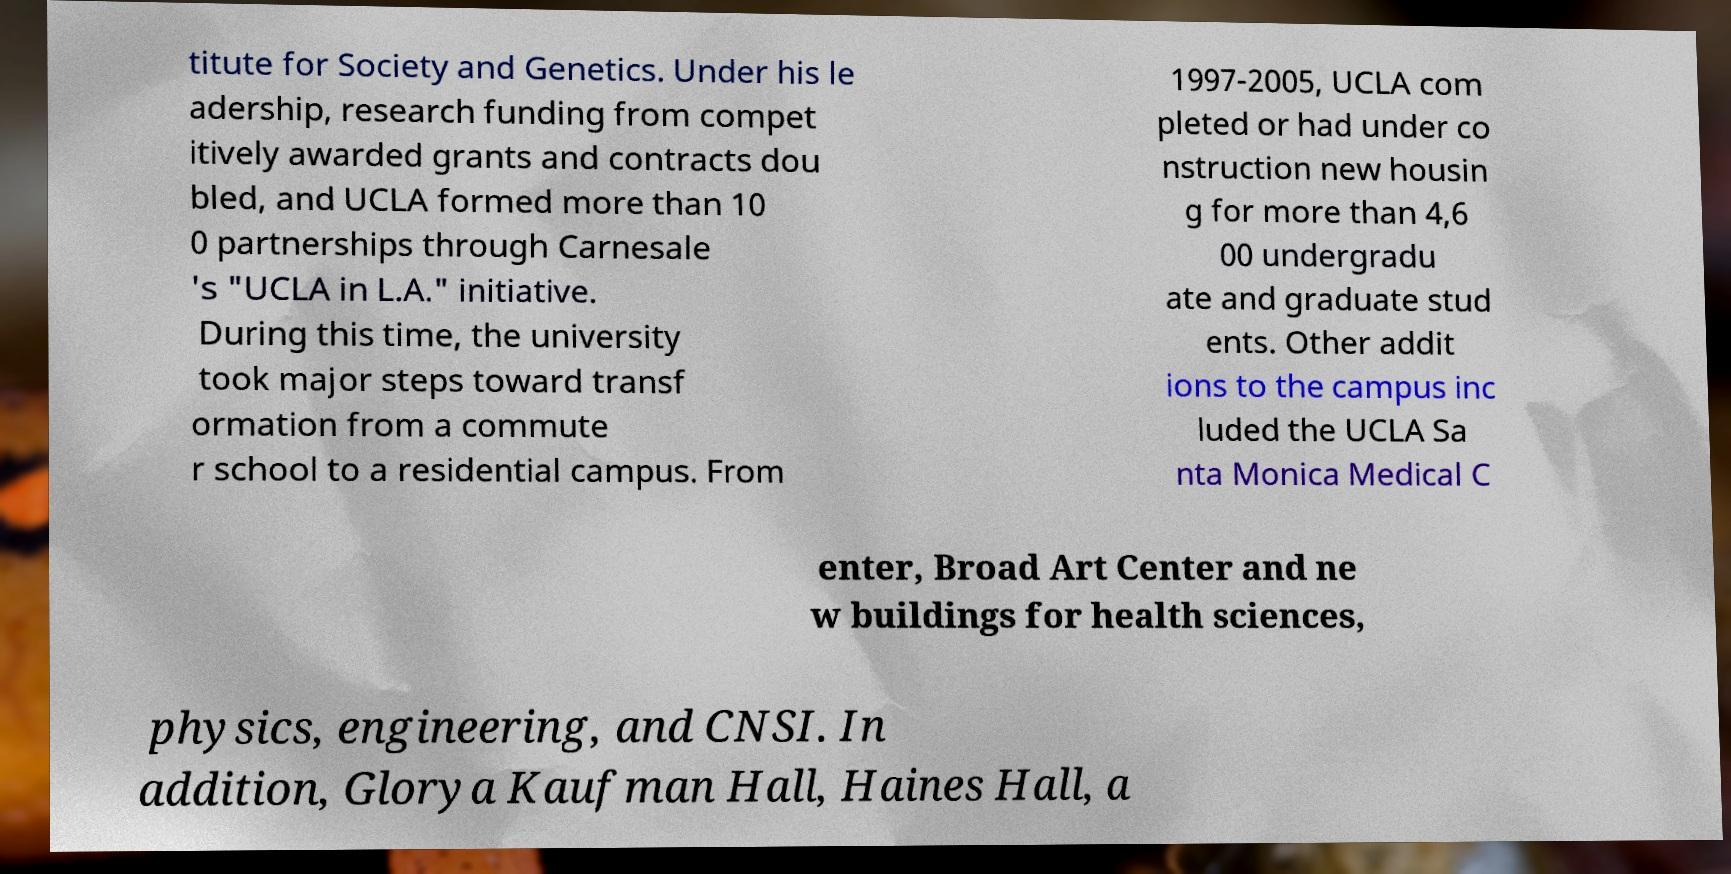For documentation purposes, I need the text within this image transcribed. Could you provide that? titute for Society and Genetics. Under his le adership, research funding from compet itively awarded grants and contracts dou bled, and UCLA formed more than 10 0 partnerships through Carnesale 's "UCLA in L.A." initiative. During this time, the university took major steps toward transf ormation from a commute r school to a residential campus. From 1997-2005, UCLA com pleted or had under co nstruction new housin g for more than 4,6 00 undergradu ate and graduate stud ents. Other addit ions to the campus inc luded the UCLA Sa nta Monica Medical C enter, Broad Art Center and ne w buildings for health sciences, physics, engineering, and CNSI. In addition, Glorya Kaufman Hall, Haines Hall, a 